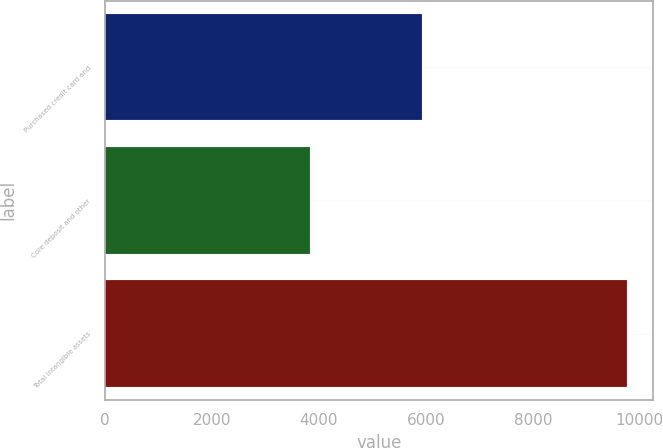Convert chart to OTSL. <chart><loc_0><loc_0><loc_500><loc_500><bar_chart><fcel>Purchased credit card and<fcel>Core deposit and other<fcel>Total intangible assets<nl><fcel>5919<fcel>3835<fcel>9754<nl></chart> 